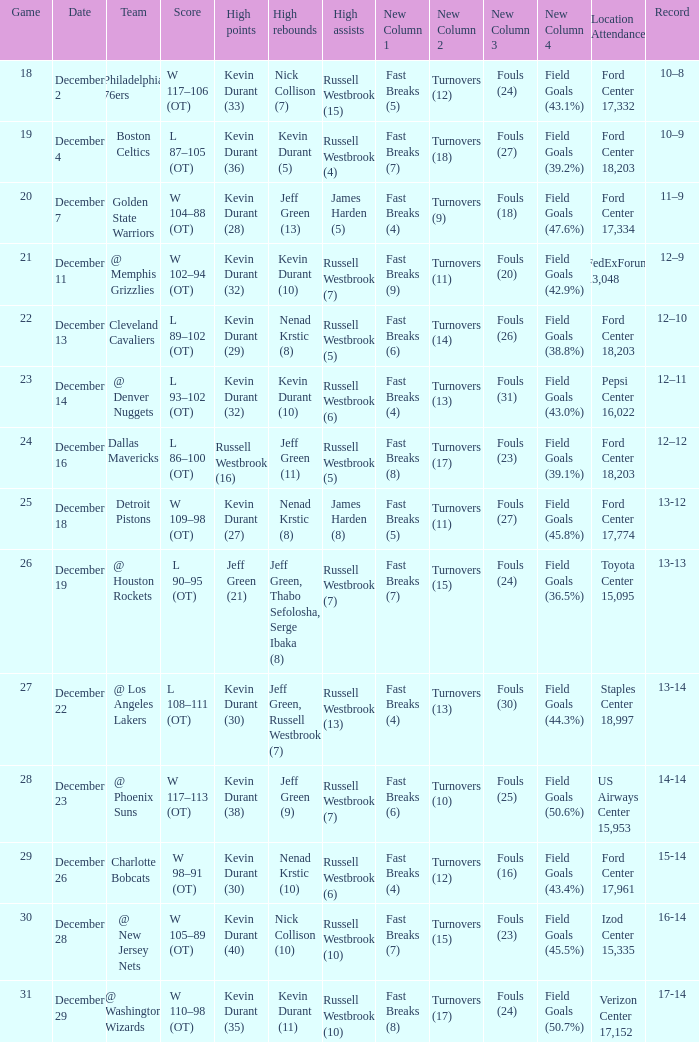What is the score for the date of December 7? W 104–88 (OT). 